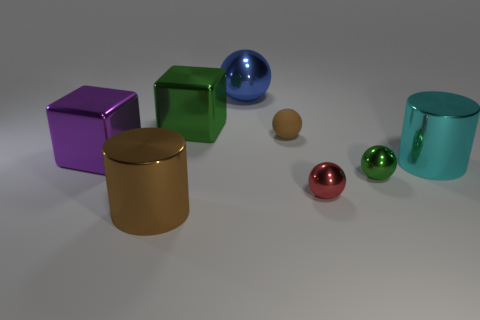Are there fewer green shiny cubes that are right of the large shiny sphere than small red shiny things that are on the left side of the green shiny cube?
Ensure brevity in your answer.  No. There is another big thing that is the same color as the rubber object; what is it made of?
Your answer should be very brief. Metal. Are there any other things that are the same shape as the purple metal object?
Offer a very short reply. Yes. There is a brown thing that is behind the cyan shiny cylinder; what material is it?
Keep it short and to the point. Rubber. Are there the same number of large cylinders and large brown shiny blocks?
Make the answer very short. No. Is there any other thing that is the same size as the brown cylinder?
Make the answer very short. Yes. Are there any shiny things to the right of the tiny red sphere?
Give a very brief answer. Yes. What shape is the big purple metal object?
Your response must be concise. Cube. How many objects are large metal blocks in front of the large green thing or big brown objects?
Your response must be concise. 2. How many other things are there of the same color as the large shiny sphere?
Offer a terse response. 0. 